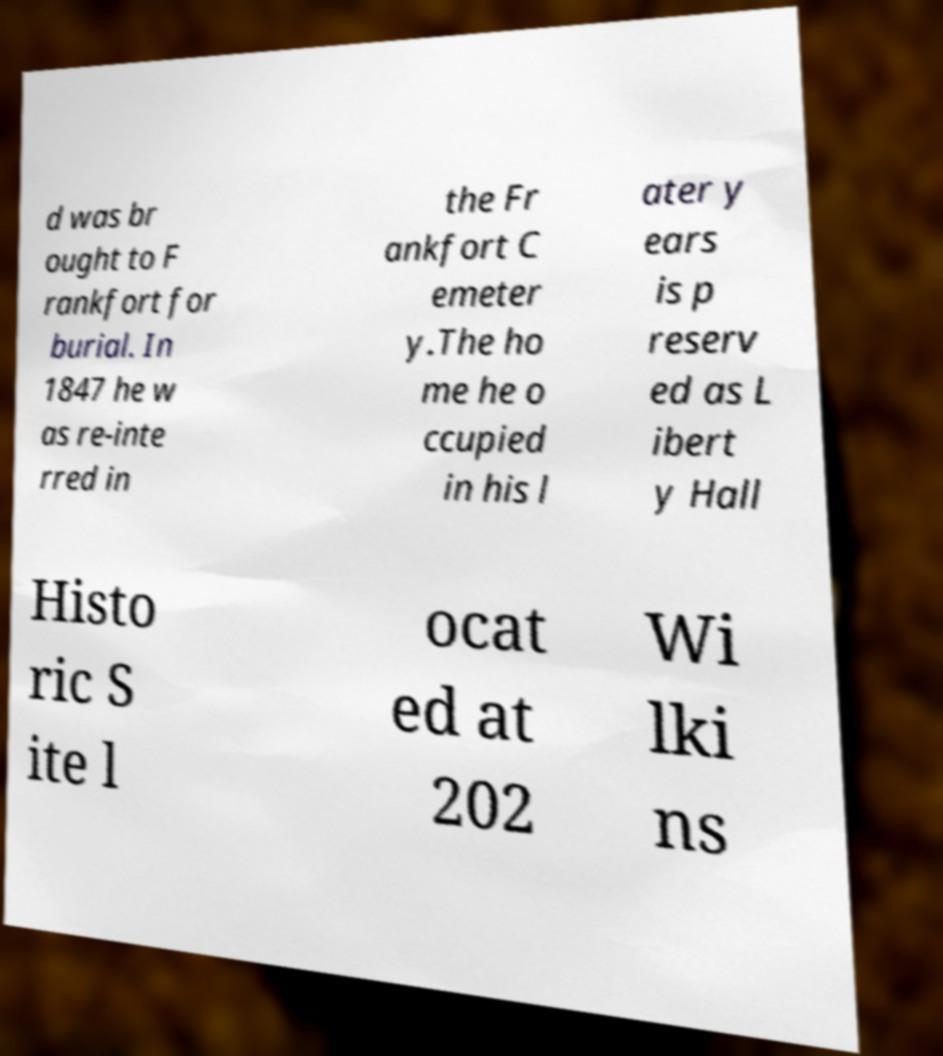What messages or text are displayed in this image? I need them in a readable, typed format. d was br ought to F rankfort for burial. In 1847 he w as re-inte rred in the Fr ankfort C emeter y.The ho me he o ccupied in his l ater y ears is p reserv ed as L ibert y Hall Histo ric S ite l ocat ed at 202 Wi lki ns 